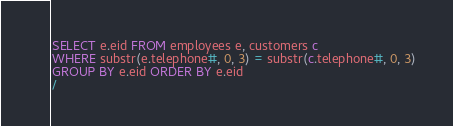<code> <loc_0><loc_0><loc_500><loc_500><_SQL_>SELECT e.eid FROM employees e, customers c
WHERE substr(e.telephone#, 0, 3) = substr(c.telephone#, 0, 3)
GROUP BY e.eid ORDER BY e.eid
/
</code> 